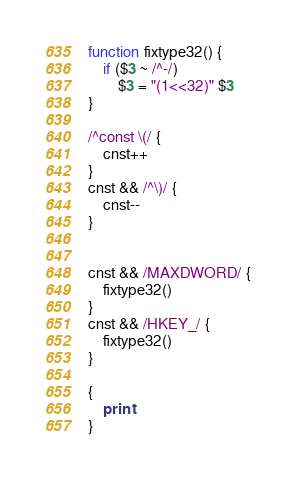<code> <loc_0><loc_0><loc_500><loc_500><_Awk_>function fixtype32() {
	if ($3 ~ /^-/)
		$3 = "(1<<32)" $3
}

/^const \(/ {
	cnst++
}
cnst && /^\)/ {
	cnst--
}


cnst && /MAXDWORD/ {
	fixtype32()
}
cnst && /HKEY_/ {
	fixtype32()
}

{
	print
}
</code> 